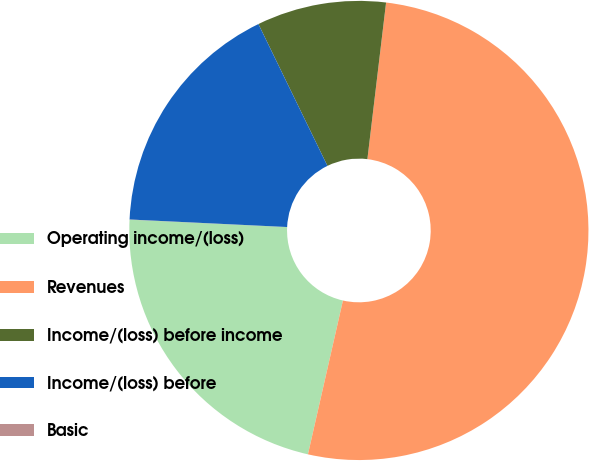<chart> <loc_0><loc_0><loc_500><loc_500><pie_chart><fcel>Operating income/(loss)<fcel>Revenues<fcel>Income/(loss) before income<fcel>Income/(loss) before<fcel>Basic<nl><fcel>22.19%<fcel>51.67%<fcel>9.1%<fcel>17.03%<fcel>0.01%<nl></chart> 